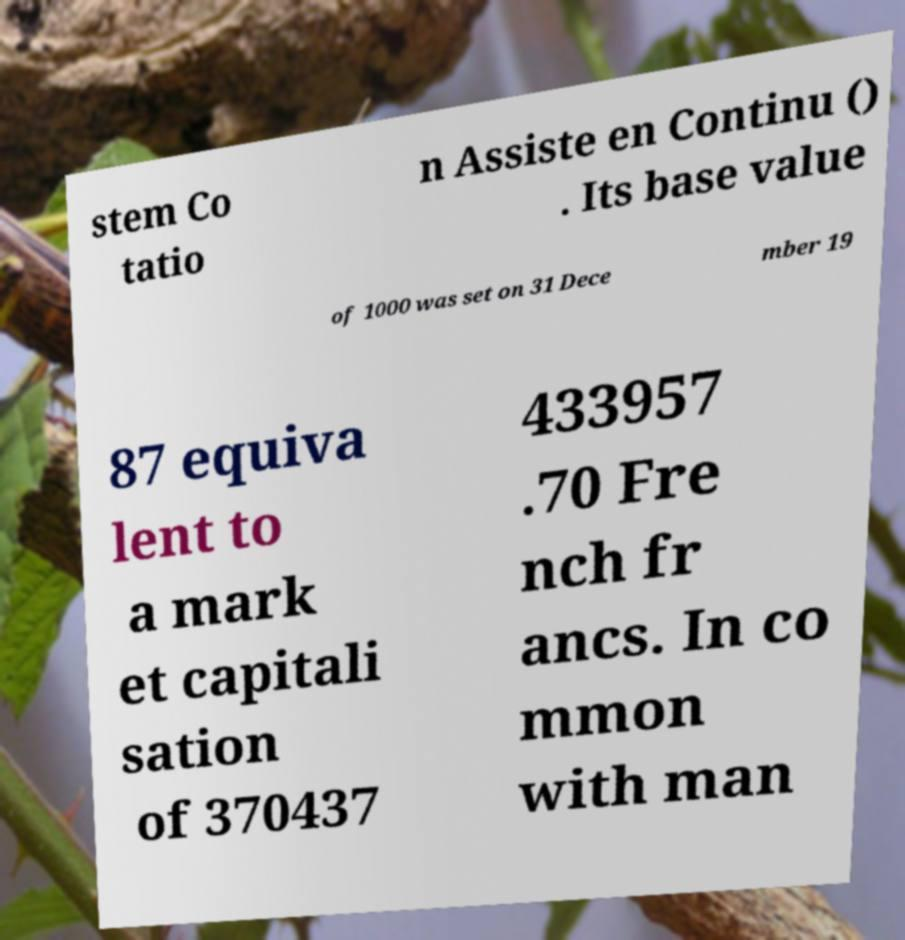Please read and relay the text visible in this image. What does it say? stem Co tatio n Assiste en Continu () . Its base value of 1000 was set on 31 Dece mber 19 87 equiva lent to a mark et capitali sation of 370437 433957 .70 Fre nch fr ancs. In co mmon with man 